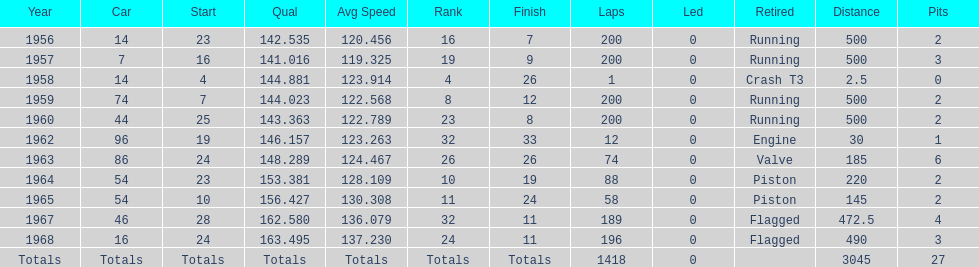How long did bob veith have the number 54 car at the indy 500? 2 years. 